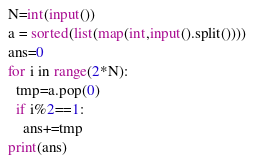<code> <loc_0><loc_0><loc_500><loc_500><_Python_>N=int(input())
a = sorted(list(map(int,input().split())))
ans=0
for i in range(2*N):
  tmp=a.pop(0)
  if i%2==1:
    ans+=tmp
print(ans)</code> 